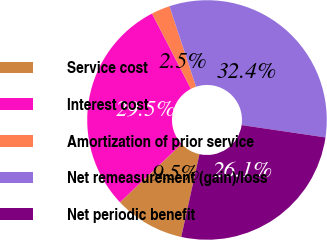Convert chart to OTSL. <chart><loc_0><loc_0><loc_500><loc_500><pie_chart><fcel>Service cost<fcel>Interest cost<fcel>Amortization of prior service<fcel>Net remeasurement (gain)/loss<fcel>Net periodic benefit<nl><fcel>9.5%<fcel>29.46%<fcel>2.51%<fcel>32.4%<fcel>26.12%<nl></chart> 